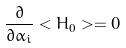Convert formula to latex. <formula><loc_0><loc_0><loc_500><loc_500>\frac { \partial } { \partial { \alpha _ { i } } } < H _ { 0 } > = 0</formula> 